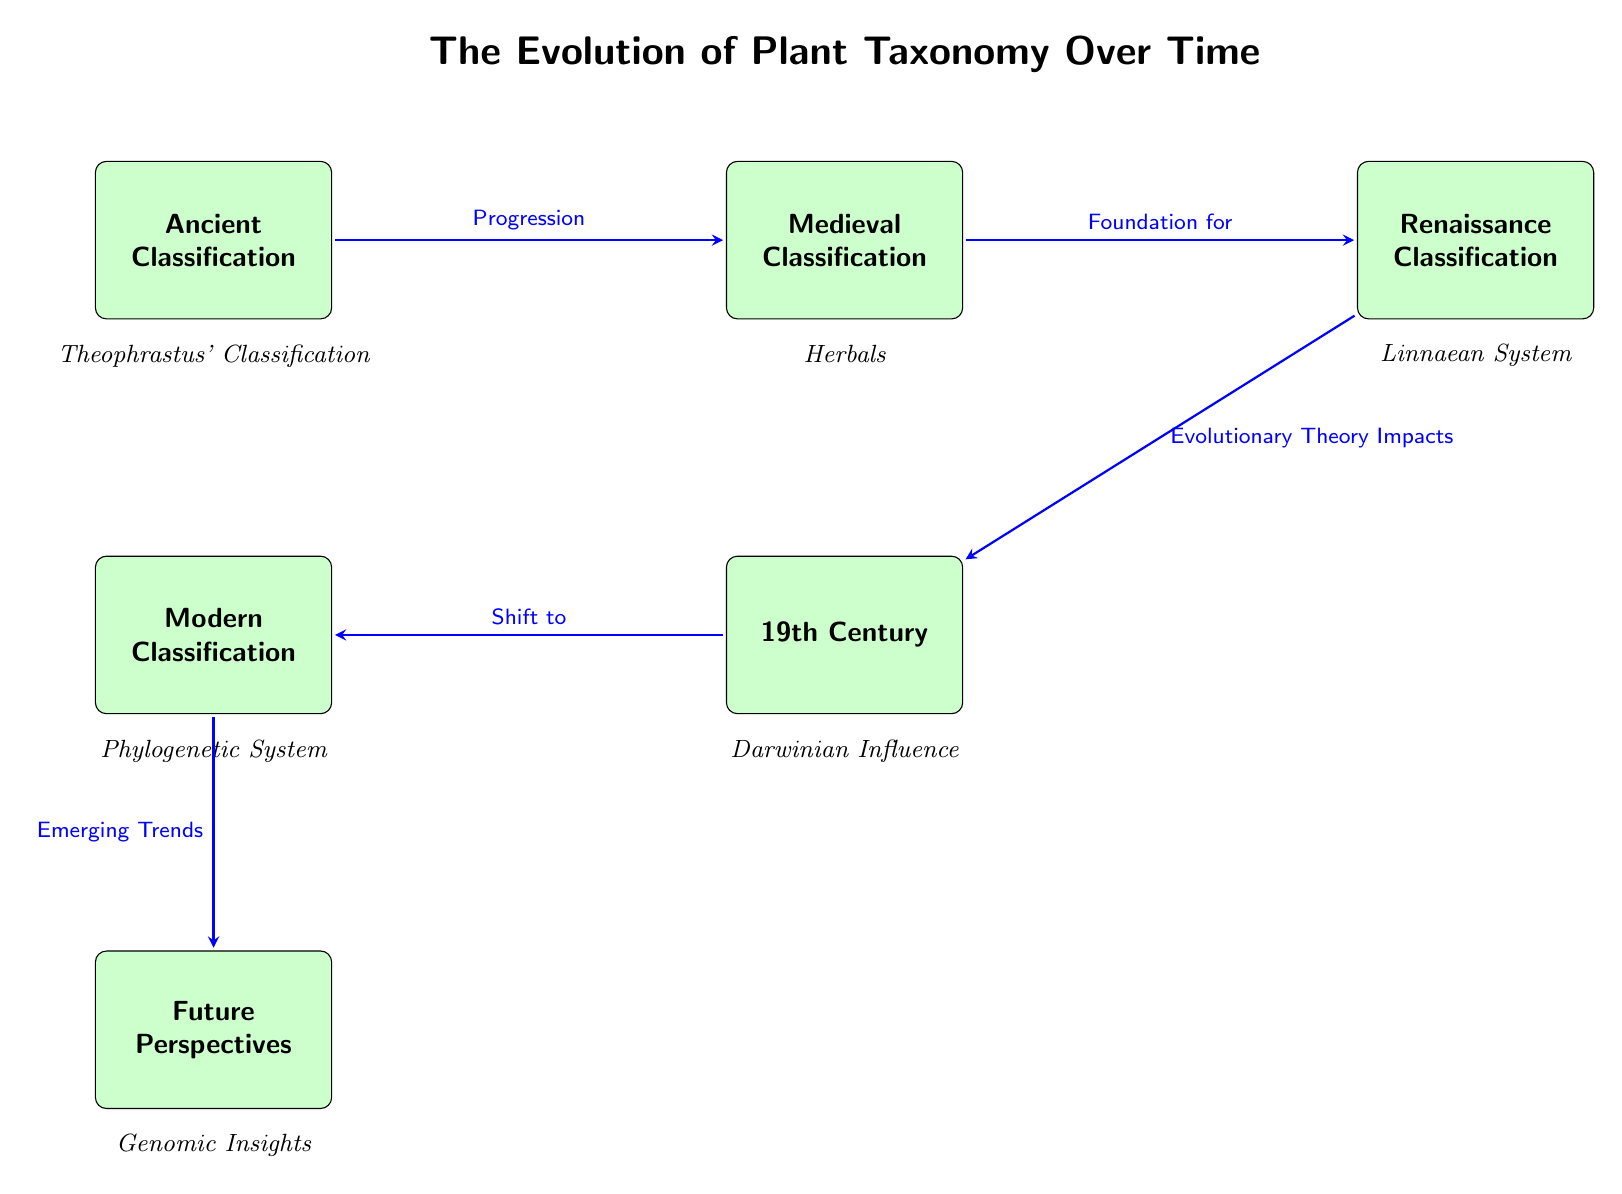What are the two classifications at the top of the diagram? The nodes at the top of the diagram are "Ancient Classification" and "Medieval Classification." These are the first two classifications that represent distinct periods in the evolution of plant taxonomy.
Answer: Ancient Classification, Medieval Classification How many classifications are shown in the diagram? By counting the number of distinct classification nodes present in the diagram, which are Ancient Classification, Medieval Classification, Renaissance Classification, 19th Century, Modern Classification, and Future Perspectives, we find there are six classifications in total.
Answer: 6 What relationship is indicated by the arrow from Medieval Classification to Renaissance Classification? The arrow from Medieval Classification to Renaissance Classification is labeled "Foundation for," showing that the Medieval Classification served as a foundational element for Renaissance Classification. This indicates a developmental flow from one classification to another.
Answer: Foundation for Which period's classification includes "Linnaean System"? The "Linnaean System" is specifically identified under the Renaissance Classification node. This classification period is known for establishing the system that continues to influence taxonomy today.
Answer: Renaissance Classification What influences the classification during the 19th Century? The "19th Century" classification is impacted by "Evolutionary Theory Impacts," as indicated by the arrow leading from the Renaissance classification to the 19th Century classification. This shows a direct influence of evolutionary theory on how plants were classified during this time.
Answer: Evolutionary Theory Impacts What is indicated as the future perspective in plant taxonomy? The diagram shows "Genomic Insights" as the future perspective in plant taxonomy, indicating a trend towards incorporating genetic information to improve classifications. This reflects the advancement of technology and research methods in botany.
Answer: Genomic Insights What trend is indicated by the arrow leading from Modern Classification to Future Perspectives? The arrow leading from Modern Classification to Future Perspectives is labeled "Emerging Trends," which suggests that current practices and understandings are evolving towards new developments that are yet to be fully realized.
Answer: Emerging Trends Which classification is directly below Medieval Classification in the diagram? Directly positioned below Medieval Classification is Renaissance Classification, indicating that Renaissance Classification is a subsequent development that follows Medieval Classification in the timeline depicted.
Answer: Renaissance Classification 